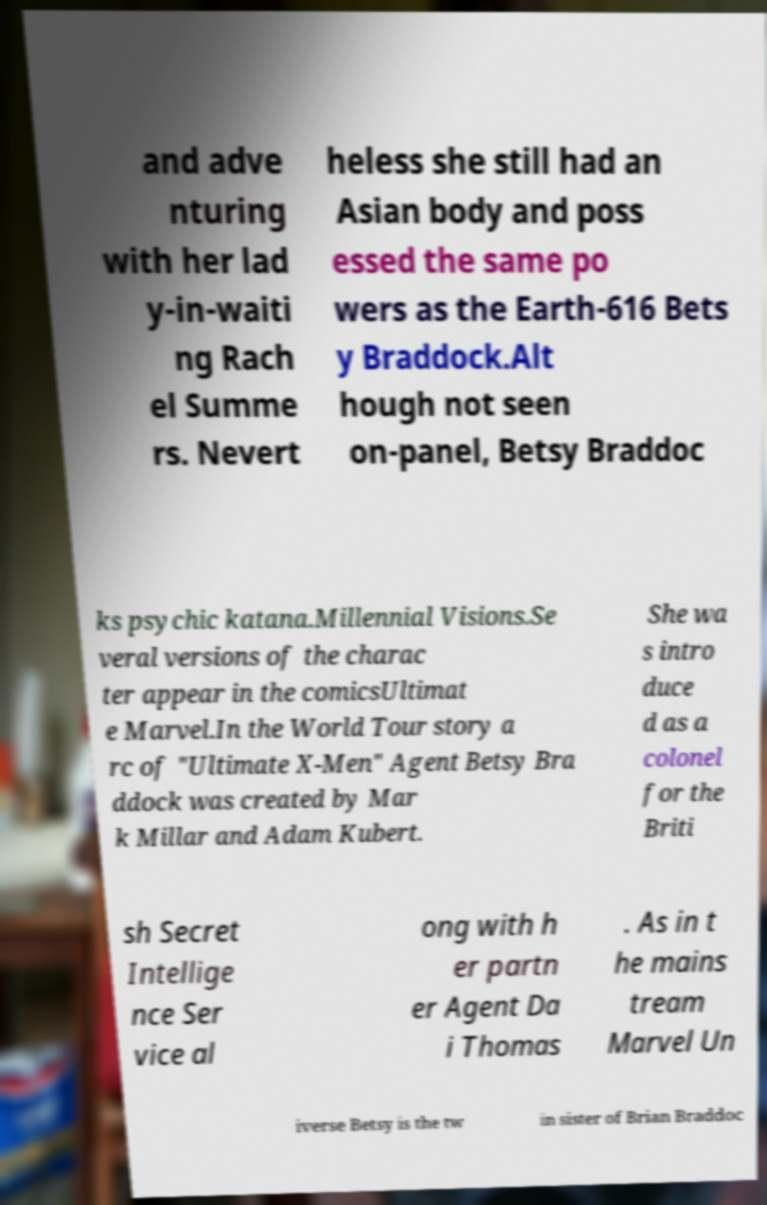Can you accurately transcribe the text from the provided image for me? and adve nturing with her lad y-in-waiti ng Rach el Summe rs. Nevert heless she still had an Asian body and poss essed the same po wers as the Earth-616 Bets y Braddock.Alt hough not seen on-panel, Betsy Braddoc ks psychic katana.Millennial Visions.Se veral versions of the charac ter appear in the comicsUltimat e Marvel.In the World Tour story a rc of "Ultimate X-Men" Agent Betsy Bra ddock was created by Mar k Millar and Adam Kubert. She wa s intro duce d as a colonel for the Briti sh Secret Intellige nce Ser vice al ong with h er partn er Agent Da i Thomas . As in t he mains tream Marvel Un iverse Betsy is the tw in sister of Brian Braddoc 